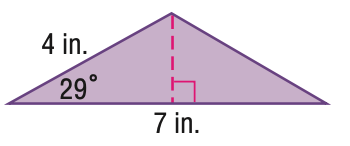Answer the mathemtical geometry problem and directly provide the correct option letter.
Question: Find the area of the triangle. Round to the nearest hundredth.
Choices: A: 3.88 B: 6.79 C: 13.58 D: 14 B 